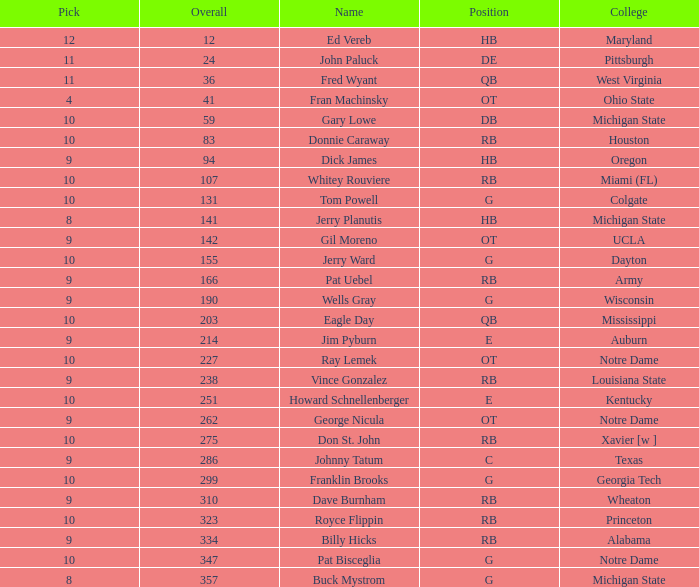What is the total number of overall picks that were after pick 9 and went to Auburn College? 0.0. 